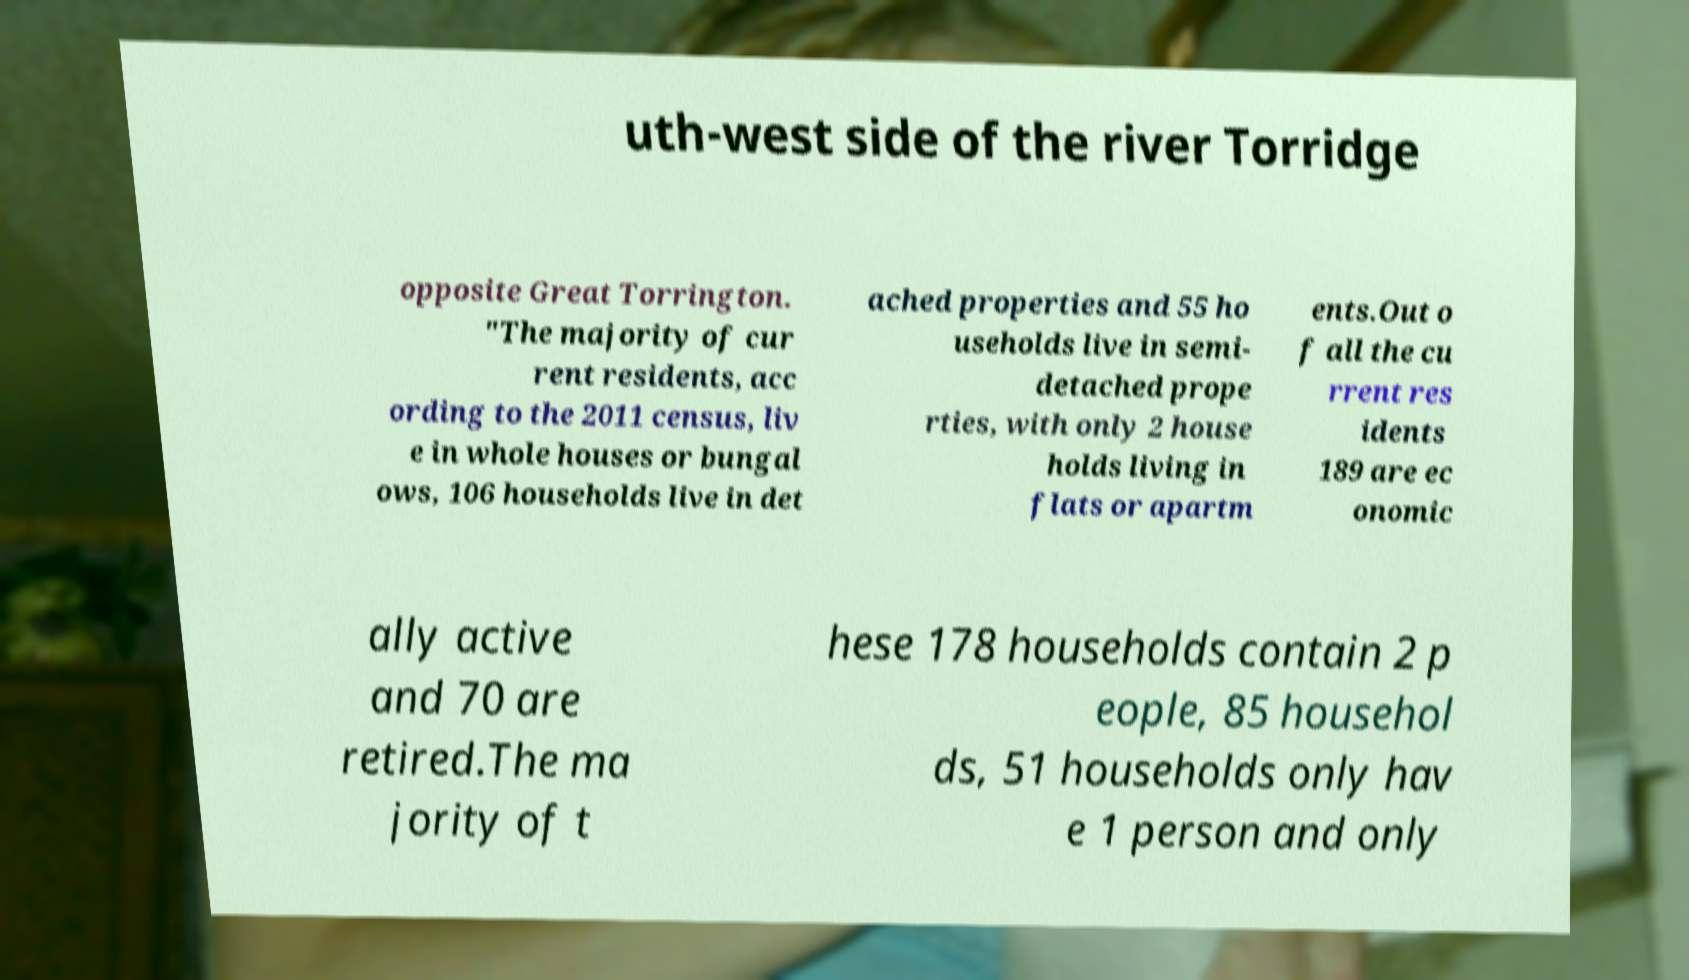For documentation purposes, I need the text within this image transcribed. Could you provide that? uth-west side of the river Torridge opposite Great Torrington. "The majority of cur rent residents, acc ording to the 2011 census, liv e in whole houses or bungal ows, 106 households live in det ached properties and 55 ho useholds live in semi- detached prope rties, with only 2 house holds living in flats or apartm ents.Out o f all the cu rrent res idents 189 are ec onomic ally active and 70 are retired.The ma jority of t hese 178 households contain 2 p eople, 85 househol ds, 51 households only hav e 1 person and only 